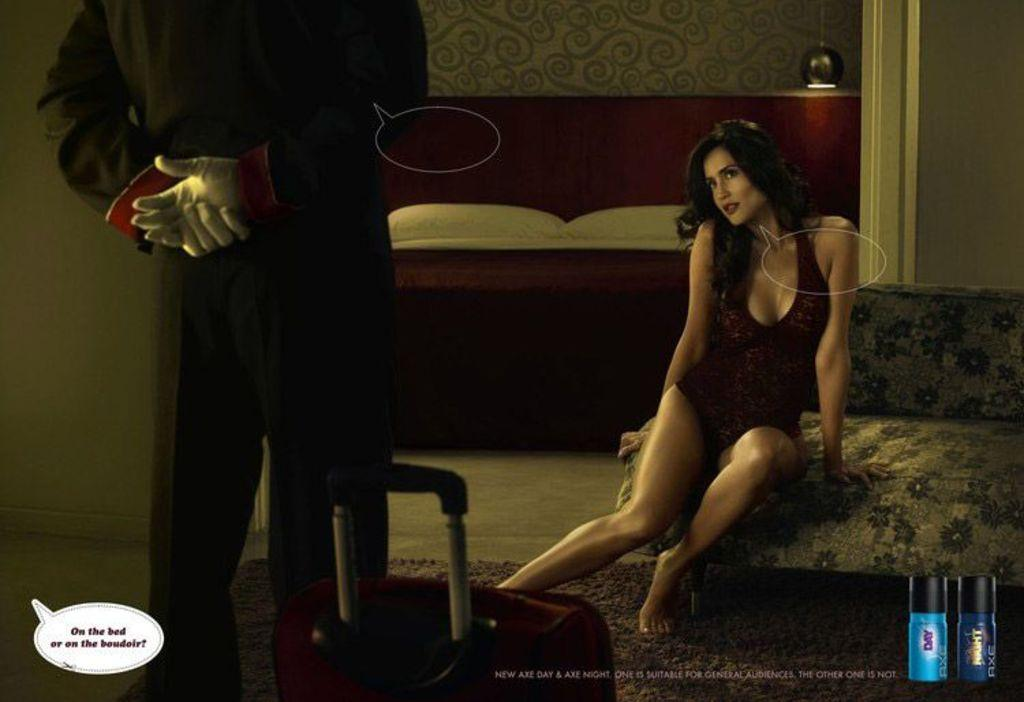What is the main subject of the image? There is a person standing in the image. What object is associated with the person in the image? There is a luggage bag in the image. What is the woman in the image doing? The woman is sitting on a sofa in the image. What can be seen in the background of the image? The background of the image includes pillows on a bed and a wall. Can you describe the lighting in the image? There is a light source in the background. What type of honey is being poured into the shoe in the image? There is no shoe or honey present in the image. 